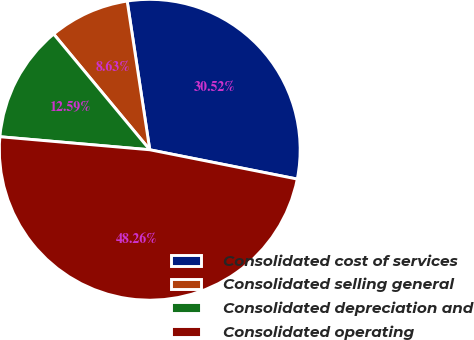Convert chart. <chart><loc_0><loc_0><loc_500><loc_500><pie_chart><fcel>Consolidated cost of services<fcel>Consolidated selling general<fcel>Consolidated depreciation and<fcel>Consolidated operating<nl><fcel>30.52%<fcel>8.63%<fcel>12.59%<fcel>48.26%<nl></chart> 